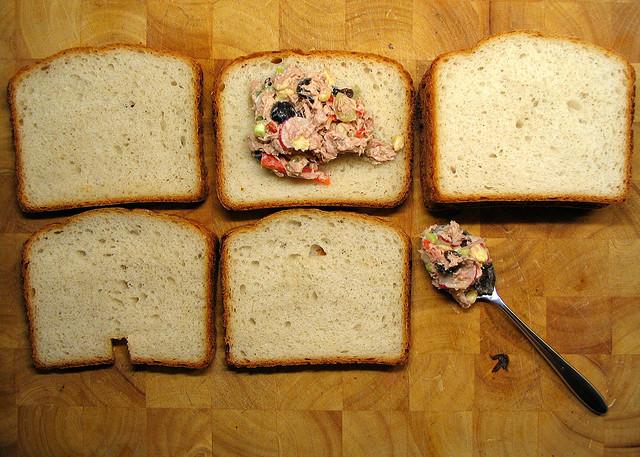Is the table wood?
Give a very brief answer. Yes. What is on the spoon?
Short answer required. Tuna salad. How many pieces of bread have food on it?
Quick response, please. 1. 